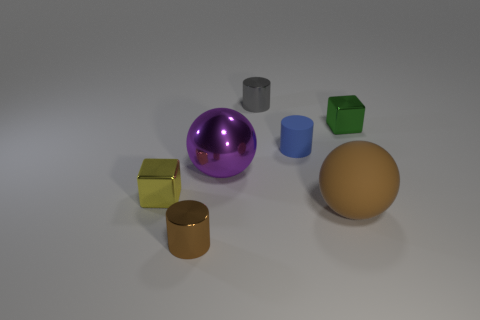What number of other brown balls have the same size as the brown matte sphere?
Provide a succinct answer. 0. Are there an equal number of blocks on the left side of the tiny green thing and yellow matte cylinders?
Keep it short and to the point. No. How many metallic things are both to the right of the blue matte cylinder and to the left of the gray metallic cylinder?
Your response must be concise. 0. The green object that is made of the same material as the purple thing is what size?
Keep it short and to the point. Small. What number of yellow objects are the same shape as the green metallic thing?
Your answer should be compact. 1. Is the number of blue cylinders that are behind the tiny gray metal object greater than the number of small purple spheres?
Provide a short and direct response. No. What shape is the small metal object that is in front of the green cube and to the right of the tiny yellow metallic block?
Offer a very short reply. Cylinder. Is the green thing the same size as the brown metal cylinder?
Provide a succinct answer. Yes. There is a big purple metal sphere; what number of big spheres are to the right of it?
Keep it short and to the point. 1. Are there the same number of purple things on the right side of the brown ball and matte cylinders on the left side of the large purple metal object?
Provide a short and direct response. Yes. 